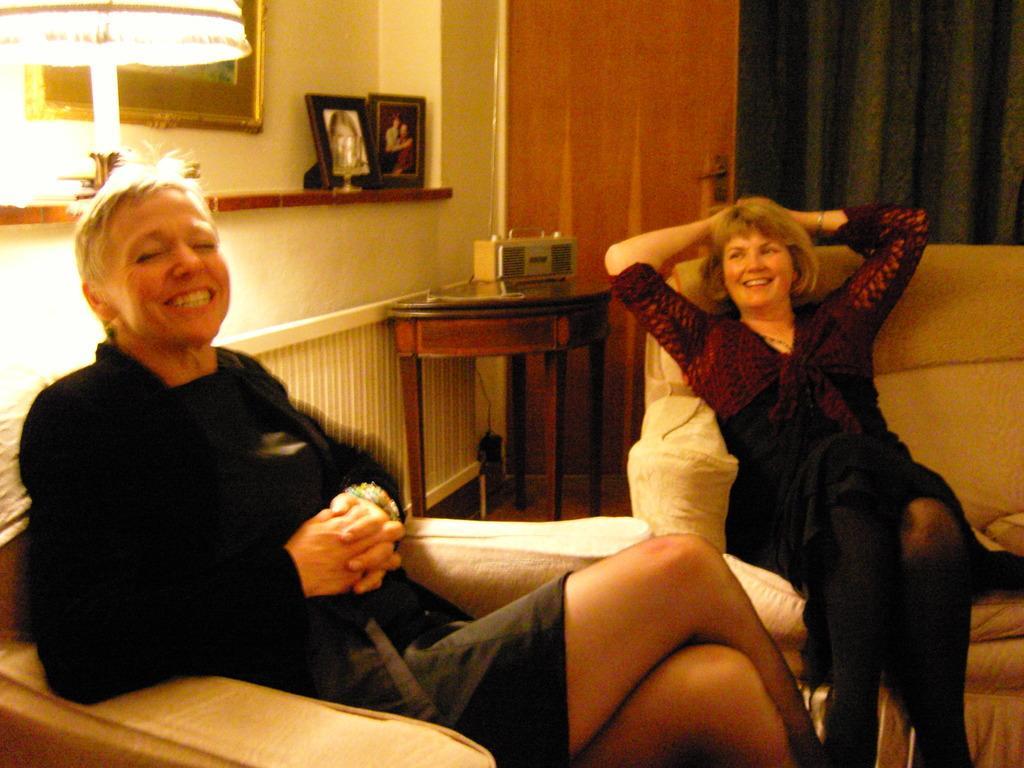Please provide a concise description of this image. In this picture we can see two women are sitting and smiling, on the left side there are photo frames, a lamp and a wall, there is a table in the middle, in the background we can see a door and a curtain, on the right side there is a sofa. 